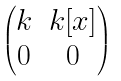<formula> <loc_0><loc_0><loc_500><loc_500>\begin{pmatrix} k & k [ x ] \\ 0 & 0 \end{pmatrix}</formula> 